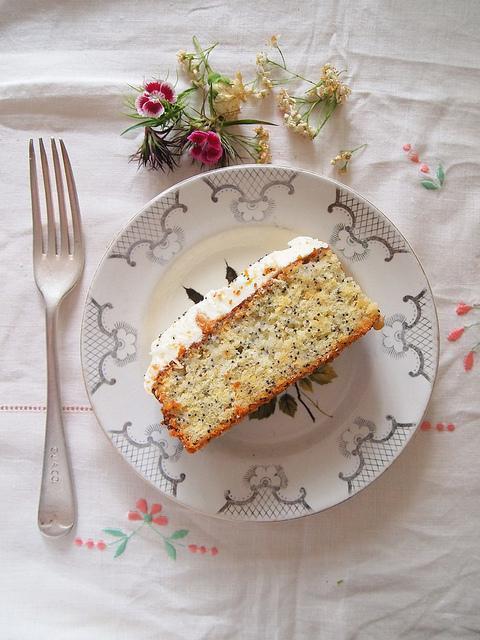How many slices have been cut?
Give a very brief answer. 1. How many forks do you see?
Give a very brief answer. 1. How many person stand there?
Give a very brief answer. 0. 